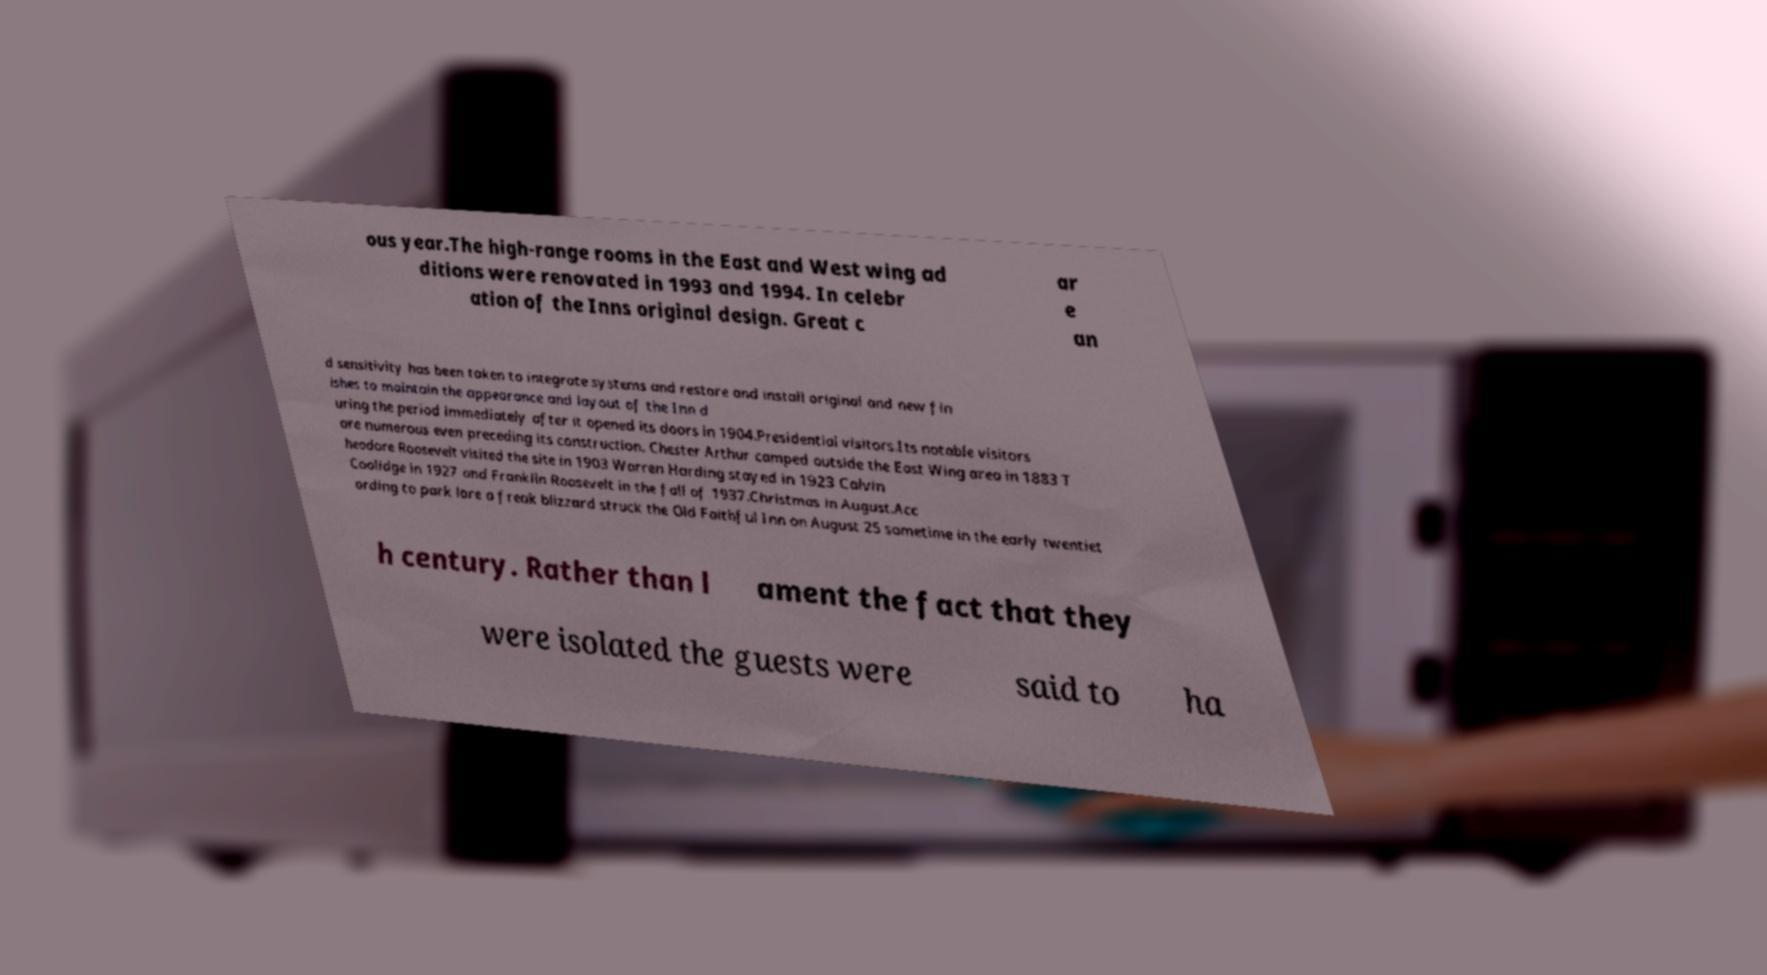For documentation purposes, I need the text within this image transcribed. Could you provide that? ous year.The high-range rooms in the East and West wing ad ditions were renovated in 1993 and 1994. In celebr ation of the Inns original design. Great c ar e an d sensitivity has been taken to integrate systems and restore and install original and new fin ishes to maintain the appearance and layout of the Inn d uring the period immediately after it opened its doors in 1904.Presidential visitors.Its notable visitors are numerous even preceding its construction. Chester Arthur camped outside the East Wing area in 1883 T heodore Roosevelt visited the site in 1903 Warren Harding stayed in 1923 Calvin Coolidge in 1927 and Franklin Roosevelt in the fall of 1937.Christmas in August.Acc ording to park lore a freak blizzard struck the Old Faithful Inn on August 25 sometime in the early twentiet h century. Rather than l ament the fact that they were isolated the guests were said to ha 